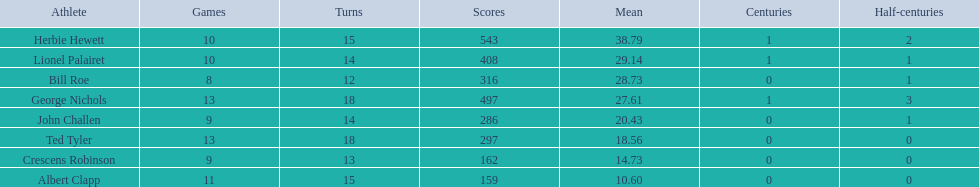How many innings did bill and ted have in total? 30. 